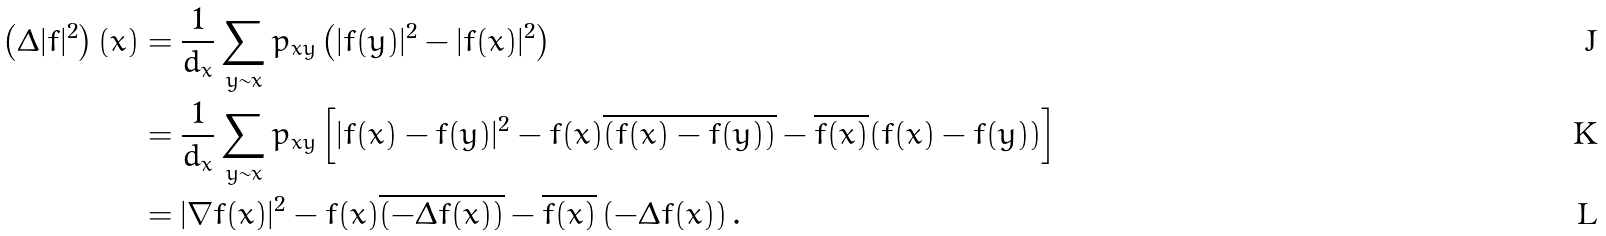<formula> <loc_0><loc_0><loc_500><loc_500>\left ( \Delta | f | ^ { 2 } \right ) ( x ) & = \frac { 1 } { d _ { x } } \sum _ { y \sim x } p _ { x y } \left ( | f ( y ) | ^ { 2 } - | f ( x ) | ^ { 2 } \right ) \\ & = \frac { 1 } { d _ { x } } \sum _ { y \sim x } p _ { x y } \left [ | f ( x ) - f ( y ) | ^ { 2 } - f ( x ) \overline { ( f ( x ) - f ( y ) ) } - \overline { f ( x ) } ( f ( x ) - f ( y ) ) \right ] \\ & = | \nabla f ( x ) | ^ { 2 } - f ( x ) \overline { \left ( - \Delta f ( x ) \right ) } - \overline { f ( x ) } \left ( - \Delta f ( x ) \right ) .</formula> 